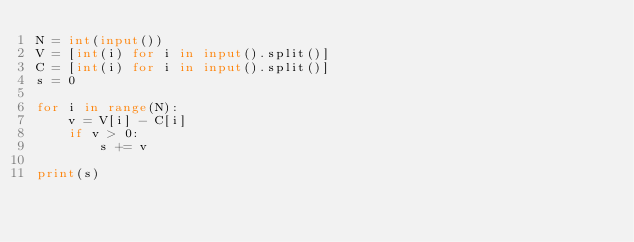<code> <loc_0><loc_0><loc_500><loc_500><_Python_>N = int(input())
V = [int(i) for i in input().split()]
C = [int(i) for i in input().split()]
s = 0

for i in range(N):
    v = V[i] - C[i]
    if v > 0:
        s += v

print(s)</code> 